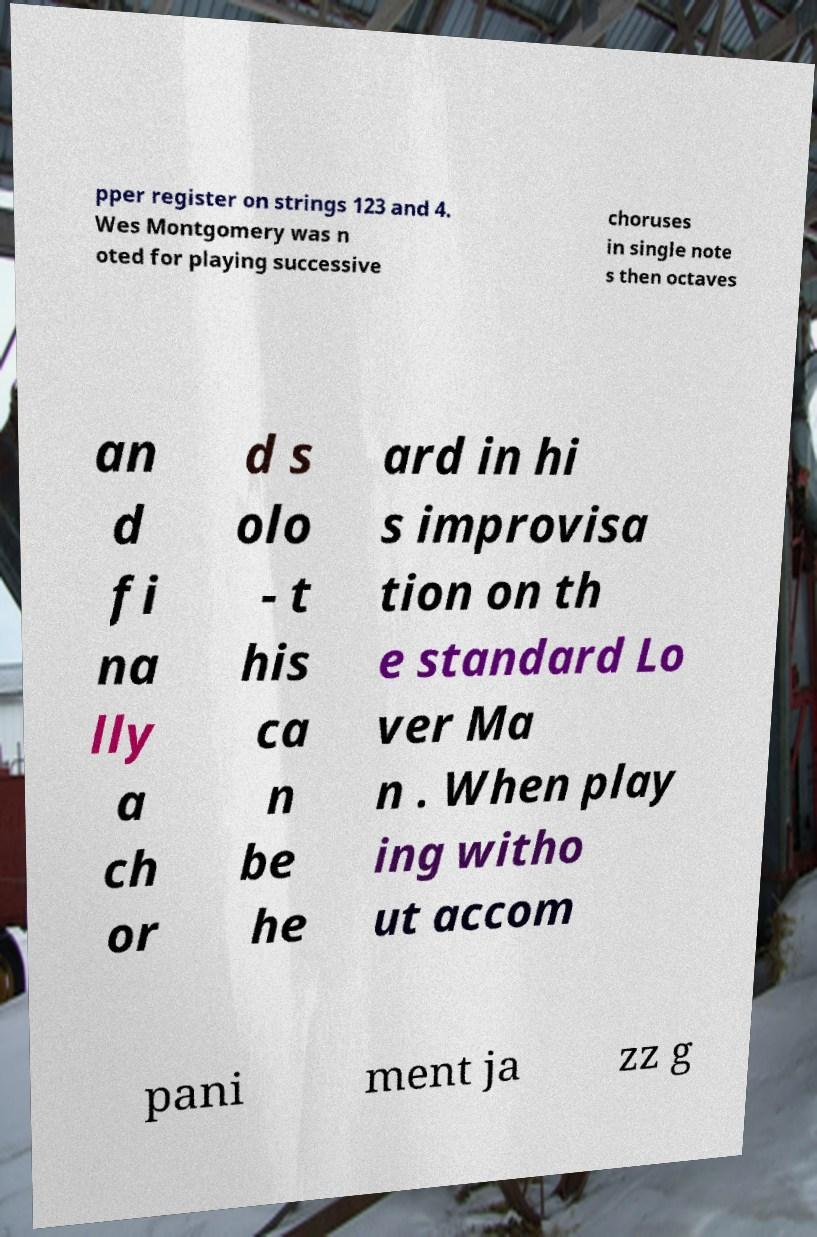For documentation purposes, I need the text within this image transcribed. Could you provide that? pper register on strings 123 and 4. Wes Montgomery was n oted for playing successive choruses in single note s then octaves an d fi na lly a ch or d s olo - t his ca n be he ard in hi s improvisa tion on th e standard Lo ver Ma n . When play ing witho ut accom pani ment ja zz g 